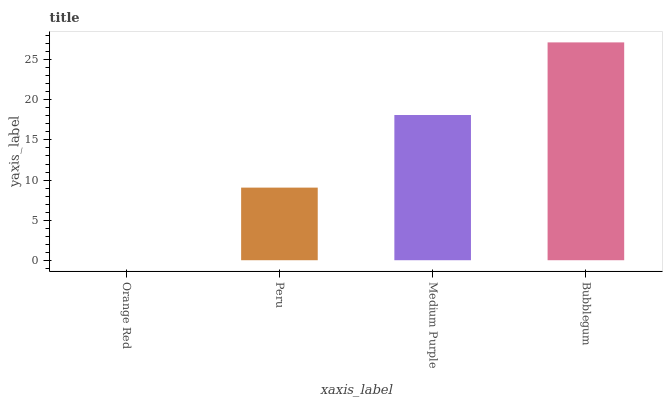Is Orange Red the minimum?
Answer yes or no. Yes. Is Bubblegum the maximum?
Answer yes or no. Yes. Is Peru the minimum?
Answer yes or no. No. Is Peru the maximum?
Answer yes or no. No. Is Peru greater than Orange Red?
Answer yes or no. Yes. Is Orange Red less than Peru?
Answer yes or no. Yes. Is Orange Red greater than Peru?
Answer yes or no. No. Is Peru less than Orange Red?
Answer yes or no. No. Is Medium Purple the high median?
Answer yes or no. Yes. Is Peru the low median?
Answer yes or no. Yes. Is Orange Red the high median?
Answer yes or no. No. Is Bubblegum the low median?
Answer yes or no. No. 